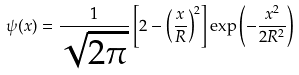Convert formula to latex. <formula><loc_0><loc_0><loc_500><loc_500>\psi ( x ) = \frac { 1 } { \sqrt { 2 \pi } } \left [ 2 - \left ( \frac { x } { R } \right ) ^ { 2 } \right ] \exp \left ( - \frac { x ^ { 2 } } { 2 R ^ { 2 } } \right )</formula> 